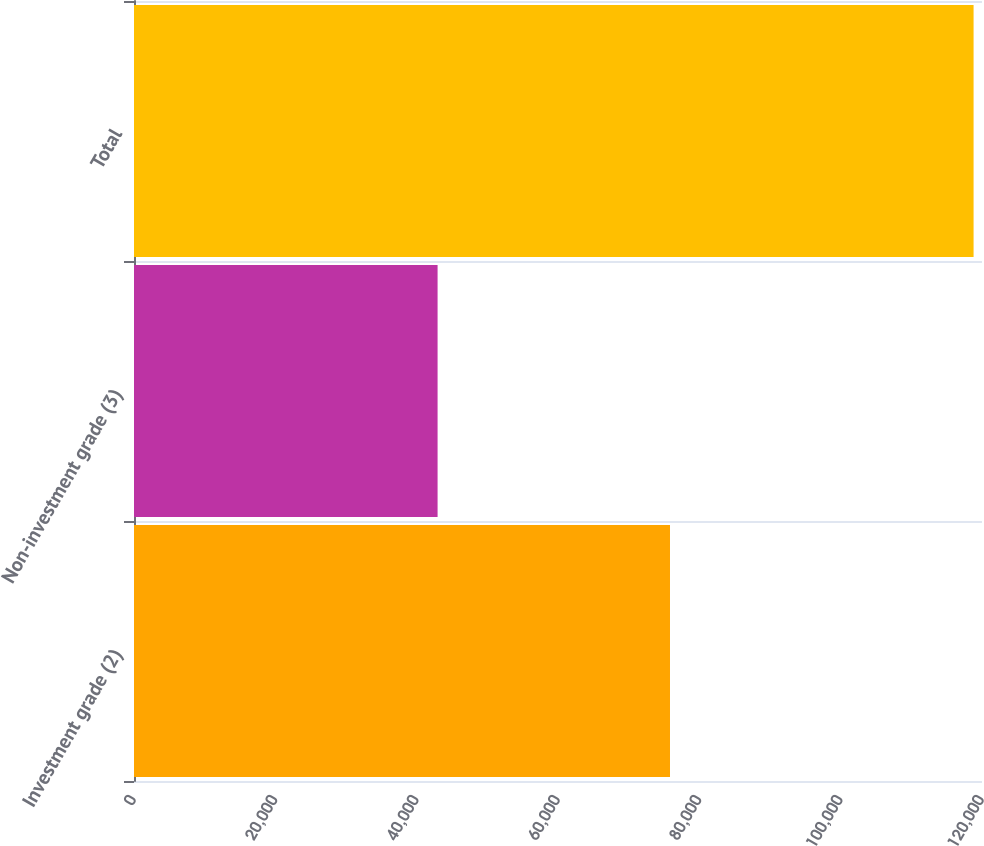<chart> <loc_0><loc_0><loc_500><loc_500><bar_chart><fcel>Investment grade (2)<fcel>Non-investment grade (3)<fcel>Total<nl><fcel>75848<fcel>42960<fcel>118808<nl></chart> 